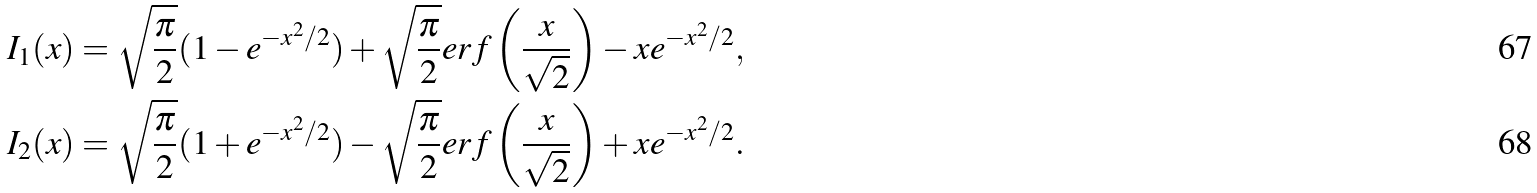Convert formula to latex. <formula><loc_0><loc_0><loc_500><loc_500>I _ { 1 } ( x ) & = \sqrt { \frac { \pi } { 2 } } ( 1 - e ^ { - x ^ { 2 } / 2 } ) + \sqrt { \frac { \pi } { 2 } } e r f \left ( \frac { x } { \sqrt { 2 } } \right ) - x e ^ { - x ^ { 2 } / 2 } , \\ I _ { 2 } ( x ) & = \sqrt { \frac { \pi } { 2 } } ( 1 + e ^ { - x ^ { 2 } / 2 } ) - \sqrt { \frac { \pi } { 2 } } e r f \left ( \frac { x } { \sqrt { 2 } } \right ) + x e ^ { - x ^ { 2 } / 2 } .</formula> 